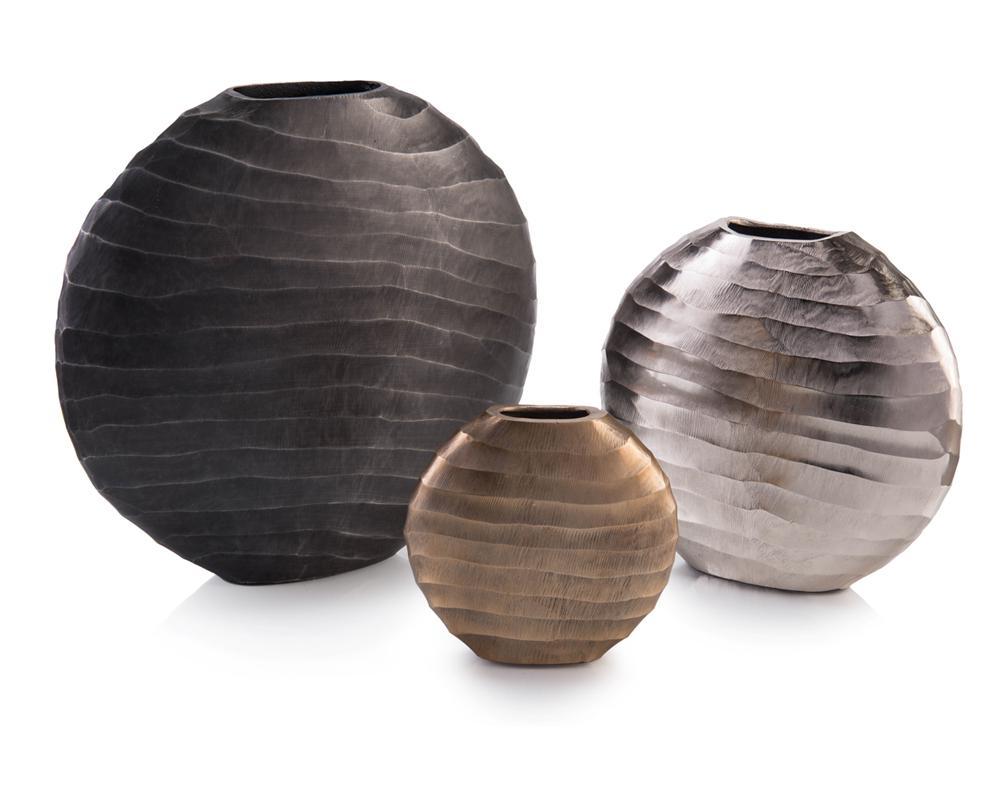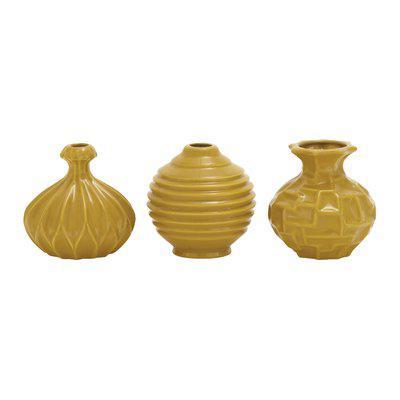The first image is the image on the left, the second image is the image on the right. For the images displayed, is the sentence "there are dark fluted vases and hammered textured ones" factually correct? Answer yes or no. No. 